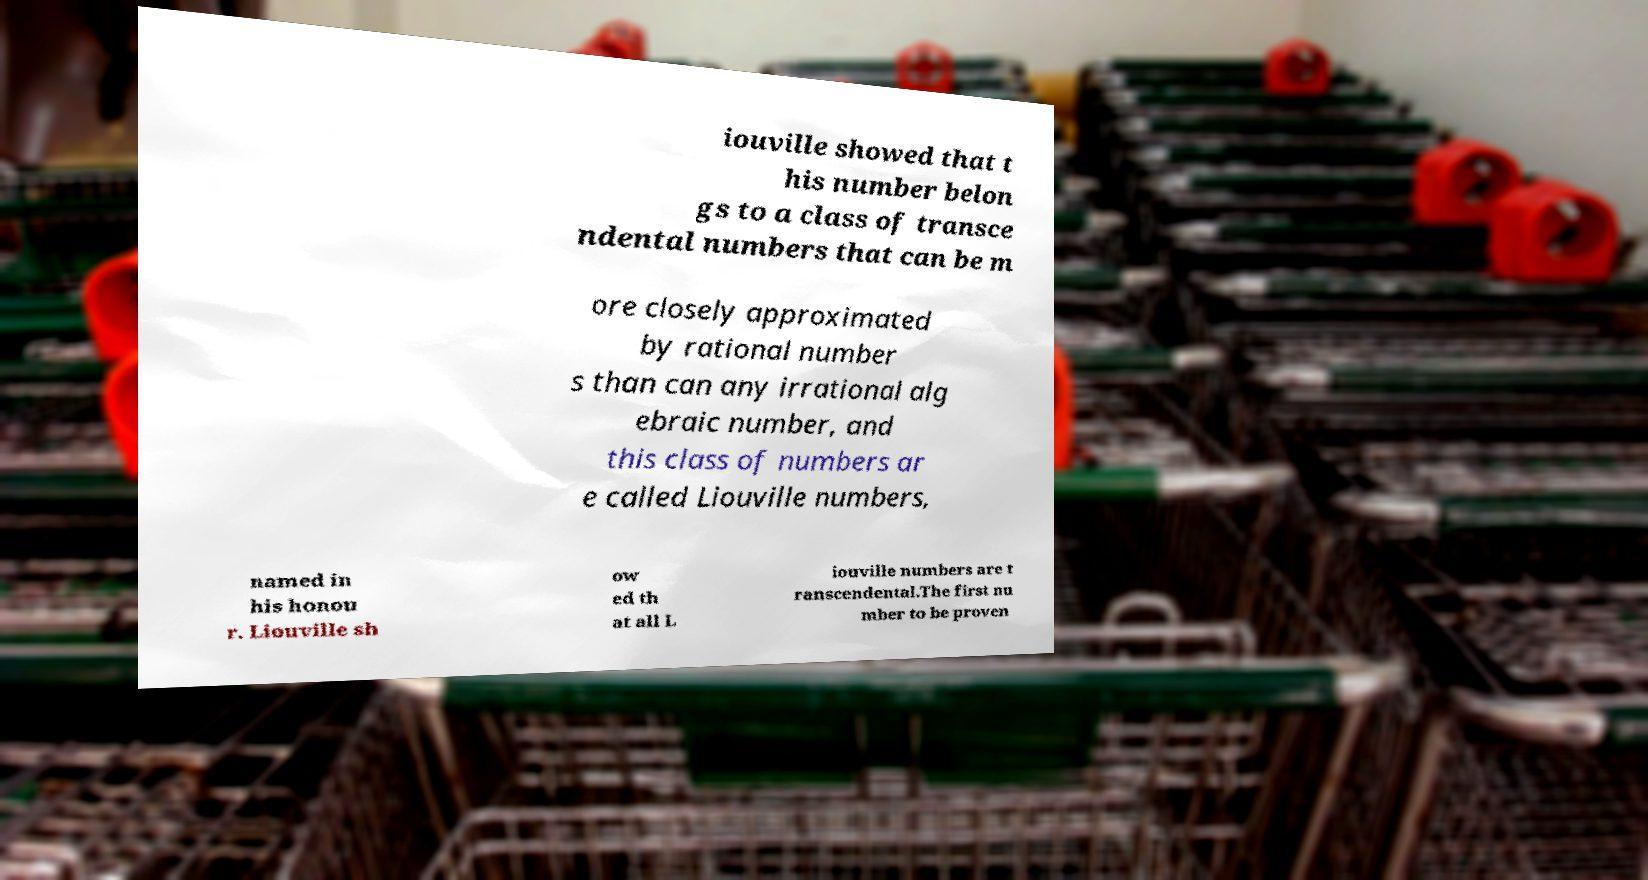Can you read and provide the text displayed in the image?This photo seems to have some interesting text. Can you extract and type it out for me? iouville showed that t his number belon gs to a class of transce ndental numbers that can be m ore closely approximated by rational number s than can any irrational alg ebraic number, and this class of numbers ar e called Liouville numbers, named in his honou r. Liouville sh ow ed th at all L iouville numbers are t ranscendental.The first nu mber to be proven 